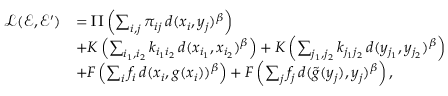<formula> <loc_0><loc_0><loc_500><loc_500>\begin{array} { r l } { \mathcal { L } ( \mathcal { E } , \mathcal { E } ^ { \prime } ) } & { = \Pi \left ( \sum _ { i , j } \pi _ { i j } \, d ( x _ { i } , y _ { j } ) ^ { \beta } \right ) } \\ & { + K \left ( \sum _ { i _ { 1 } , i _ { 2 } } k _ { i _ { 1 } i _ { 2 } } \, d ( x _ { i _ { 1 } } , x _ { i _ { 2 } } ) ^ { \beta } \right ) + K \left ( \sum _ { j _ { 1 } , j _ { 2 } } k _ { j _ { 1 } j _ { 2 } } \, d ( y _ { j _ { 1 } } , y _ { j _ { 2 } } ) ^ { \beta } \right ) } \\ & { + F \left ( \sum _ { i } f _ { i } \, d ( x _ { i } , g ( x _ { i } ) ) ^ { \beta } \right ) + F \left ( \sum _ { j } f _ { j } \, d ( \tilde { g } ( y _ { j } ) , y _ { j } ) ^ { \beta } \right ) , } \end{array}</formula> 